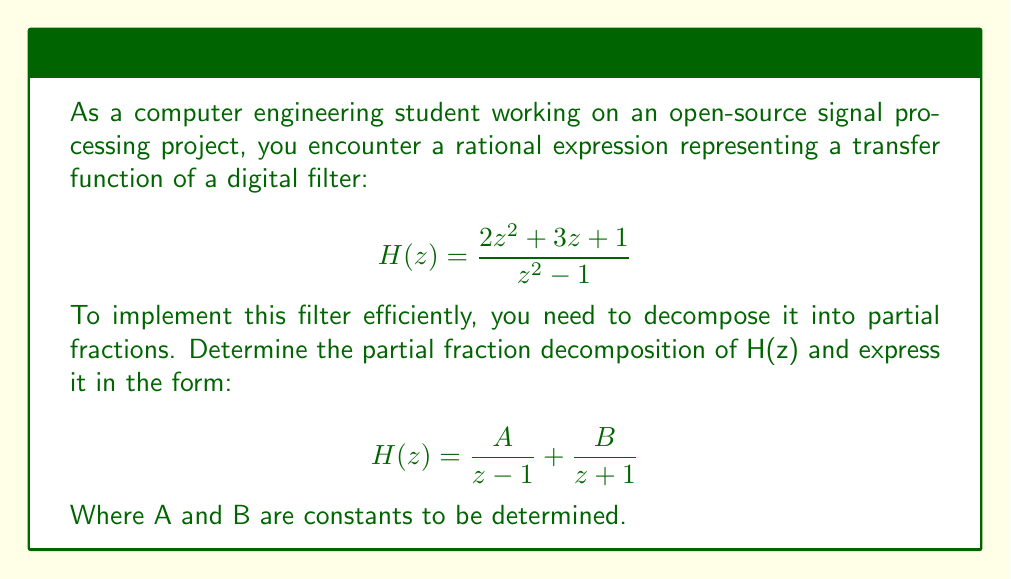Can you answer this question? Let's approach this step-by-step:

1) First, we set up the partial fraction decomposition:

   $$\frac{2z^2 + 3z + 1}{z^2 - 1} = \frac{A}{z-1} + \frac{B}{z+1}$$

2) Multiply both sides by $(z^2 - 1)$:

   $$(2z^2 + 3z + 1) = A(z+1) + B(z-1)$$

3) Expand the right side:

   $$(2z^2 + 3z + 1) = (A+B)z + (A-B)$$

4) Compare coefficients:
   
   $2z^2 + 3z + 1 = (A+B)z + (A-B)$

   Comparing coefficients:
   $z^2: 2 = 0$
   $z^1: 3 = A+B$
   $z^0: 1 = A-B$

5) Solve the system of equations:
   
   $A+B = 3$
   $A-B = 1$

   Adding these equations:
   $2A = 4$
   $A = 2$

   Subtracting the equations:
   $2B = 2$
   $B = 1$

6) Therefore, the partial fraction decomposition is:

   $$H(z) = \frac{2}{z-1} + \frac{1}{z+1}$$

This decomposition allows for efficient implementation in signal processing applications, as it breaks down the complex rational expression into simpler terms that can be processed independently.
Answer: $$H(z) = \frac{2}{z-1} + \frac{1}{z+1}$$ 